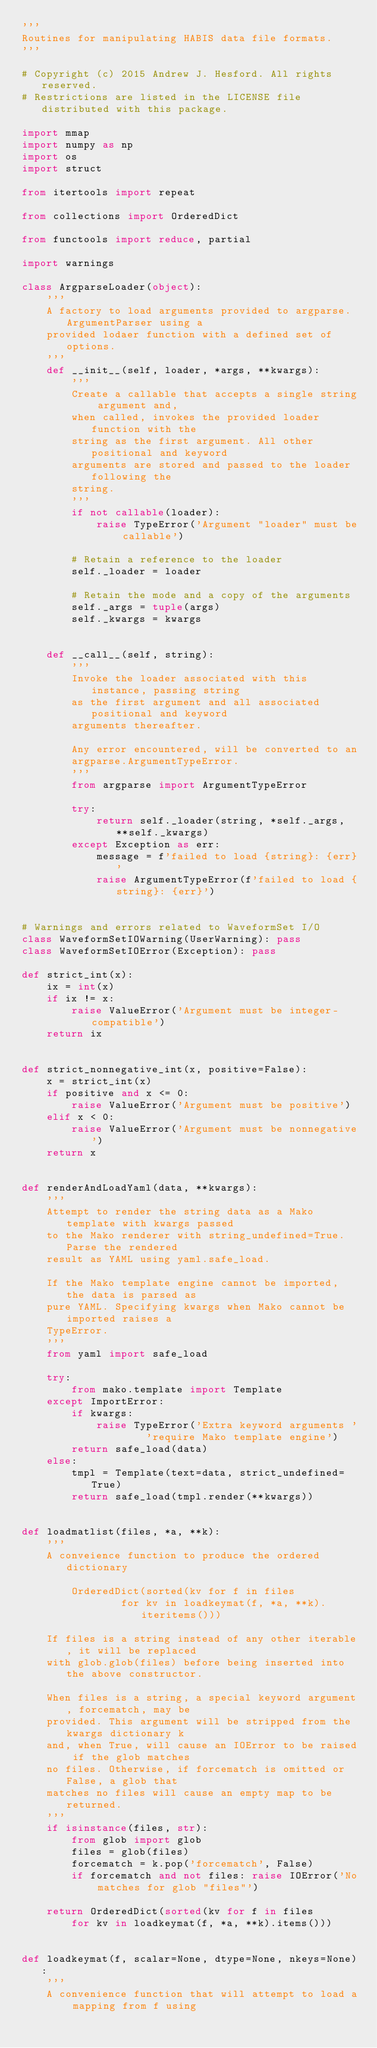<code> <loc_0><loc_0><loc_500><loc_500><_Python_>'''
Routines for manipulating HABIS data file formats.
'''

# Copyright (c) 2015 Andrew J. Hesford. All rights reserved.
# Restrictions are listed in the LICENSE file distributed with this package.

import mmap
import numpy as np
import os
import struct

from itertools import repeat

from collections import OrderedDict

from functools import reduce, partial

import warnings

class ArgparseLoader(object):
	'''
	A factory to load arguments provided to argparse.ArgumentParser using a
	provided lodaer function with a defined set of options.
	'''
	def __init__(self, loader, *args, **kwargs):
		'''
		Create a callable that accepts a single string argument and,
		when called, invokes the provided loader function with the
		string as the first argument. All other positional and keyword
		arguments are stored and passed to the loader following the
		string.
		'''
		if not callable(loader):
			raise TypeError('Argument "loader" must be callable')

		# Retain a reference to the loader
		self._loader = loader

		# Retain the mode and a copy of the arguments
		self._args = tuple(args)
		self._kwargs = kwargs


	def __call__(self, string):
		'''
		Invoke the loader associated with this instance, passing string
		as the first argument and all associated positional and keyword
		arguments thereafter.

		Any error encountered, will be converted to an
		argparse.ArgumentTypeError.
		'''
		from argparse import ArgumentTypeError

		try:
			return self._loader(string, *self._args, **self._kwargs)
		except Exception as err:
			message = f'failed to load {string}: {err}'
			raise ArgumentTypeError(f'failed to load {string}: {err}')


# Warnings and errors related to WaveformSet I/O
class WaveformSetIOWarning(UserWarning): pass
class WaveformSetIOError(Exception): pass

def strict_int(x):
	ix = int(x)
	if ix != x:
		raise ValueError('Argument must be integer-compatible')
	return ix


def strict_nonnegative_int(x, positive=False):
	x = strict_int(x)
	if positive and x <= 0:
		raise ValueError('Argument must be positive')
	elif x < 0:
		raise ValueError('Argument must be nonnegative')
	return x


def renderAndLoadYaml(data, **kwargs):
	'''
	Attempt to render the string data as a Mako template with kwargs passed
	to the Mako renderer with string_undefined=True. Parse the rendered
	result as YAML using yaml.safe_load.

	If the Mako template engine cannot be imported, the data is parsed as
	pure YAML. Specifying kwargs when Mako cannot be imported raises a
	TypeError.
	'''
	from yaml import safe_load

	try:
		from mako.template import Template
	except ImportError:
		if kwargs:
			raise TypeError('Extra keyword arguments '
					'require Mako template engine')
		return safe_load(data)
	else:
		tmpl = Template(text=data, strict_undefined=True)
		return safe_load(tmpl.render(**kwargs))


def loadmatlist(files, *a, **k):
	'''
	A conveience function to produce the ordered dictionary

		OrderedDict(sorted(kv for f in files
				for kv in loadkeymat(f, *a, **k).iteritems()))

	If files is a string instead of any other iterable, it will be replaced
	with glob.glob(files) before being inserted into the above constructor.

	When files is a string, a special keyword argument, forcematch, may be
	provided. This argument will be stripped from the kwargs dictionary k
	and, when True, will cause an IOError to be raised if the glob matches
	no files. Otherwise, if forcematch is omitted or False, a glob that
	matches no files will cause an empty map to be returned.
	'''
	if isinstance(files, str):
		from glob import glob
		files = glob(files)
		forcematch = k.pop('forcematch', False)
		if forcematch and not files: raise IOError('No matches for glob "files"')

	return OrderedDict(sorted(kv for f in files
		for kv in loadkeymat(f, *a, **k).items()))


def loadkeymat(f, scalar=None, dtype=None, nkeys=None):
	'''
	A convenience function that will attempt to load a mapping from f using</code> 